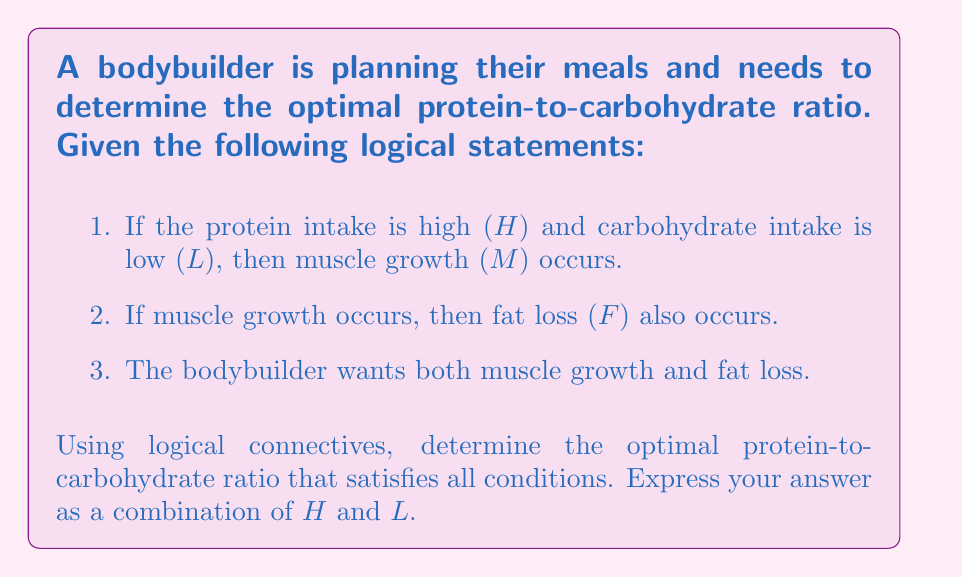Show me your answer to this math problem. Let's approach this step-by-step using propositional logic:

1) First, let's define our propositions:
   H: Protein intake is high
   L: Carbohydrate intake is low
   M: Muscle growth occurs
   F: Fat loss occurs

2) Now, let's translate the given statements into logical expressions:
   Statement 1: $H \land L \rightarrow M$
   Statement 2: $M \rightarrow F$
   Statement 3: The bodybuilder wants $M \land F$

3) We need to prove that $H \land L$ leads to both $M$ and $F$. Let's use a logical deduction:

   a) Given: $H \land L$
   b) From statement 1: $H \land L \rightarrow M$
   c) By Modus Ponens: $M$
   d) From statement 2: $M \rightarrow F$
   e) By Modus Ponens: $F$

4) Therefore, we have proved that $H \land L \rightarrow (M \land F)$

5) This means that a high protein (H) and low carbohydrate (L) intake satisfies all the conditions, leading to both muscle growth and fat loss.

Thus, the optimal protein-to-carbohydrate ratio is represented by $H \land L$, which means high protein and low carbohydrate.
Answer: $H \land L$ 